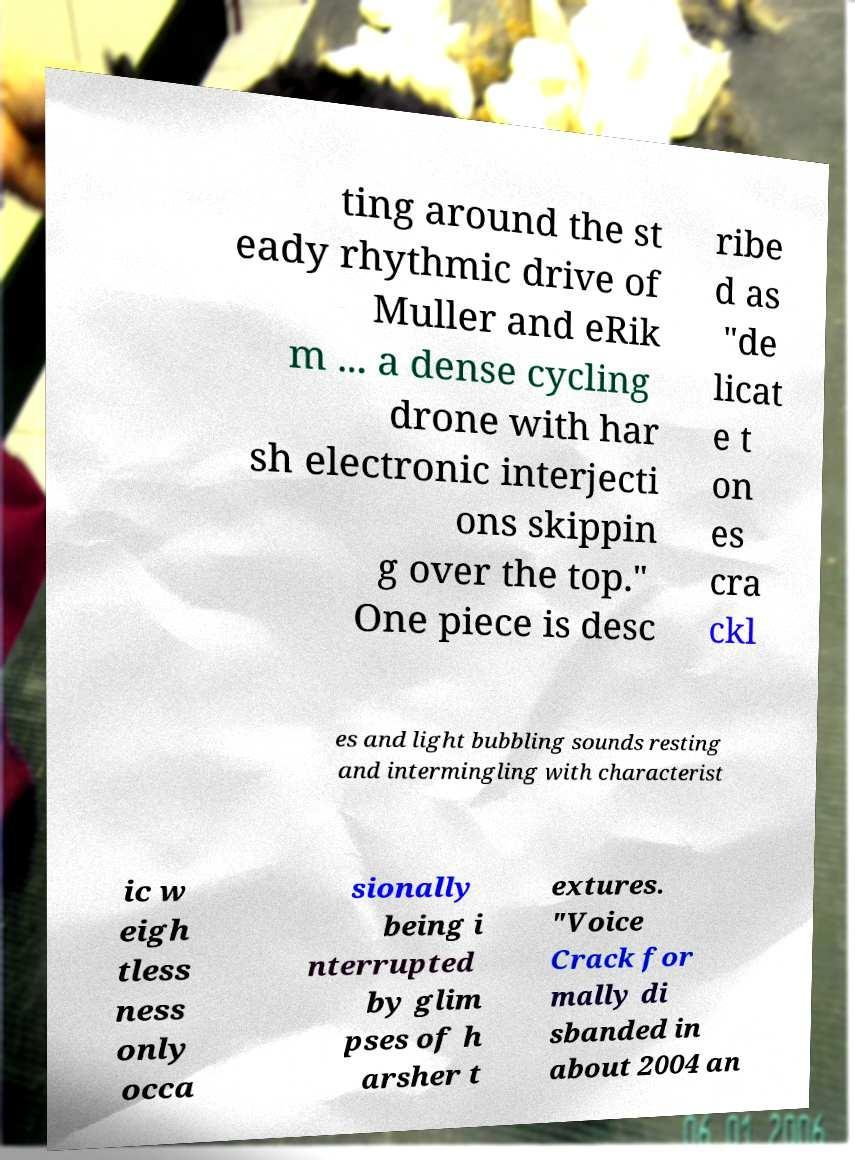Could you assist in decoding the text presented in this image and type it out clearly? ting around the st eady rhythmic drive of Muller and eRik m ... a dense cycling drone with har sh electronic interjecti ons skippin g over the top." One piece is desc ribe d as "de licat e t on es cra ckl es and light bubbling sounds resting and intermingling with characterist ic w eigh tless ness only occa sionally being i nterrupted by glim pses of h arsher t extures. "Voice Crack for mally di sbanded in about 2004 an 